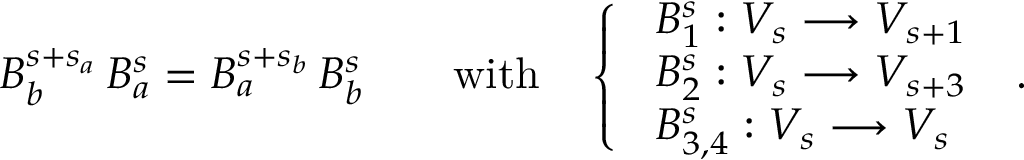<formula> <loc_0><loc_0><loc_500><loc_500>\begin{array} { r } { B _ { b } ^ { s + s _ { a } } \, B _ { a } ^ { s } = B _ { a } ^ { s + s _ { b } } \, B _ { b } ^ { s } \quad w i t h \quad \left \{ \begin{array} { l l } { \ B _ { 1 } ^ { s } \colon V _ { s } \longrightarrow V _ { s + 1 } } \\ { \ B _ { 2 } ^ { s } \colon V _ { s } \longrightarrow V _ { s + 3 } } \\ { \ B _ { 3 , 4 } ^ { s } \colon V _ { s } \longrightarrow V _ { s } } \end{array} \ . } \end{array}</formula> 